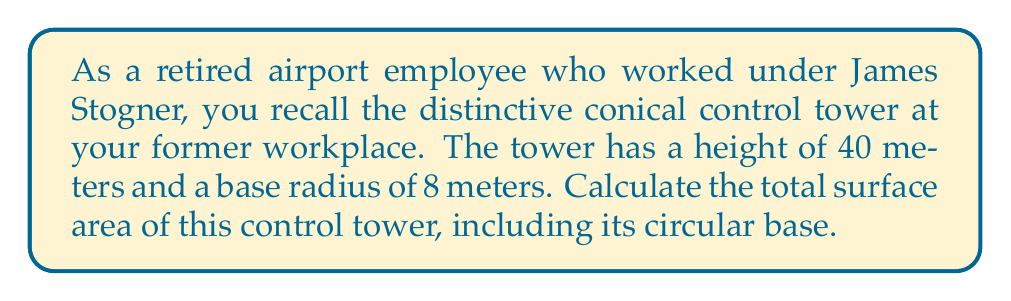Help me with this question. To solve this problem, we need to follow these steps:

1. Calculate the slant height of the cone using the Pythagorean theorem:
   $$l = \sqrt{r^2 + h^2}$$
   where $l$ is the slant height, $r$ is the radius, and $h$ is the height.
   
   $$l = \sqrt{8^2 + 40^2} = \sqrt{64 + 1600} = \sqrt{1664} = 40.79\text{ m}$$

2. Calculate the lateral surface area of the cone:
   $$A_{\text{lateral}} = \pi r l$$
   $$A_{\text{lateral}} = \pi \cdot 8 \cdot 40.79 = 1024.79\text{ m}^2$$

3. Calculate the area of the circular base:
   $$A_{\text{base}} = \pi r^2$$
   $$A_{\text{base}} = \pi \cdot 8^2 = 201.06\text{ m}^2$$

4. Sum up the lateral surface area and the base area to get the total surface area:
   $$A_{\text{total}} = A_{\text{lateral}} + A_{\text{base}}$$
   $$A_{\text{total}} = 1024.79 + 201.06 = 1225.85\text{ m}^2$$

[asy]
import geometry;

size(200);
real r = 4;
real h = 20;

pair O = (0,0);
pair A = (r,0);
pair B = (0,h);

draw(O--A--B--O);
draw(arc(O,r,0,180));
draw((-r,0)--(r,0),dashed);

label("$r$", (r/2,0), S);
label("$h$", (0,h/2), W);
label("$l$", (r/2,h/2), NE);
</asy>
Answer: $1225.85\text{ m}^2$ 